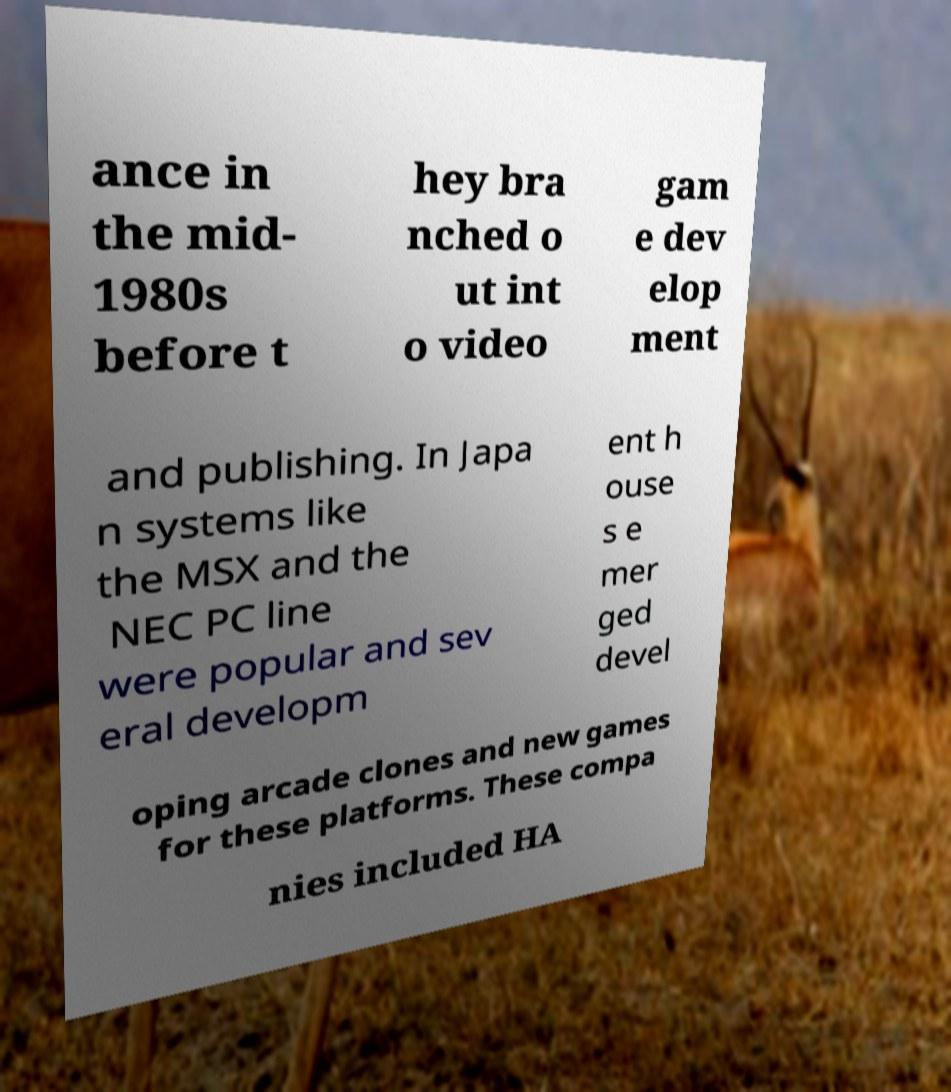There's text embedded in this image that I need extracted. Can you transcribe it verbatim? ance in the mid- 1980s before t hey bra nched o ut int o video gam e dev elop ment and publishing. In Japa n systems like the MSX and the NEC PC line were popular and sev eral developm ent h ouse s e mer ged devel oping arcade clones and new games for these platforms. These compa nies included HA 